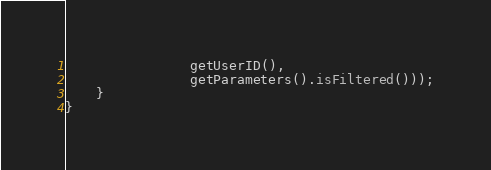<code> <loc_0><loc_0><loc_500><loc_500><_Java_>                getUserID(),
                getParameters().isFiltered()));
    }
}
</code> 